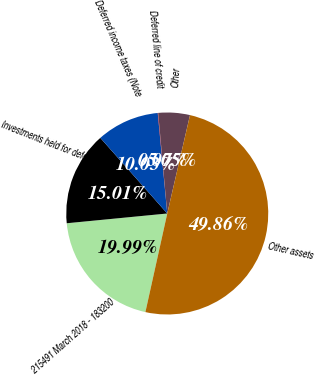Convert chart to OTSL. <chart><loc_0><loc_0><loc_500><loc_500><pie_chart><fcel>215491 March 2018 - 183200<fcel>Investments held for deferred<fcel>Deferred income taxes (Note<fcel>Deferred line of credit<fcel>Other<fcel>Other assets<nl><fcel>19.99%<fcel>15.01%<fcel>10.03%<fcel>0.07%<fcel>5.05%<fcel>49.86%<nl></chart> 